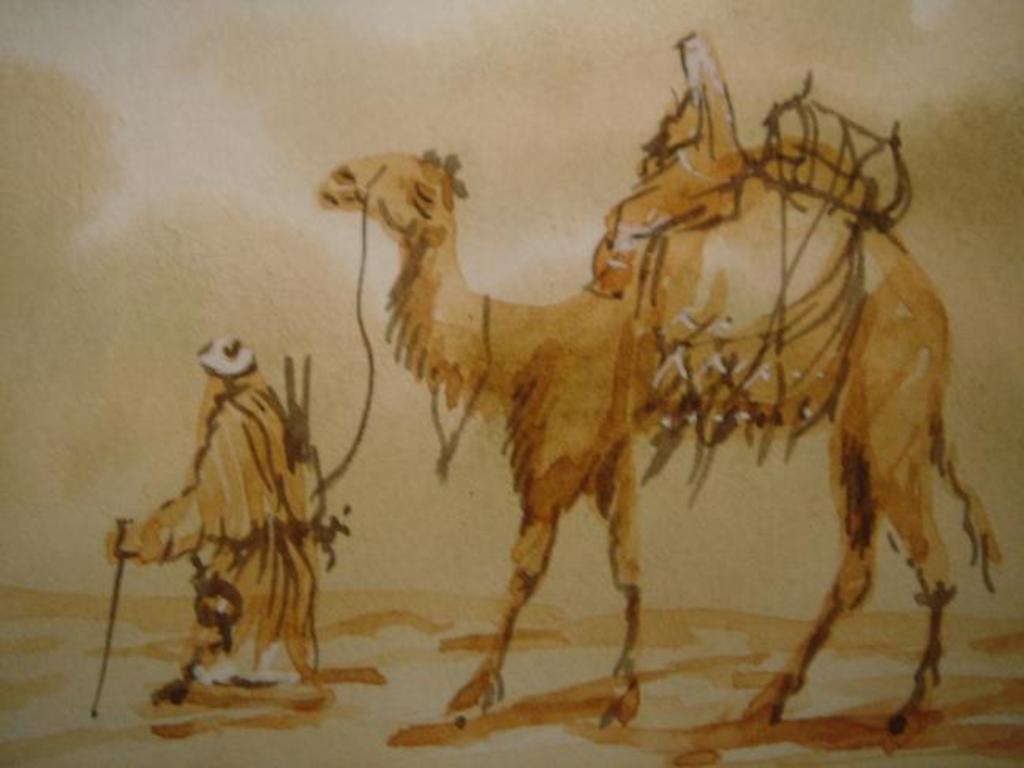What type of artwork is depicted in the image? The image appears to be a painting. Who or what can be seen in the painting? There is a man and a camel in the painting. How are the man and the camel positioned in relation to each other? The man is standing next to the camel. Is there anyone else in the painting? Yes, there is another person sitting on the camel. What can be observed about the setting of the painting? The background of the painting consists of sand. What type of cloth is being used to cover the lunchroom table in the painting? There is no lunchroom table or cloth present in the painting; it features a man, a camel, and a sandy background. 